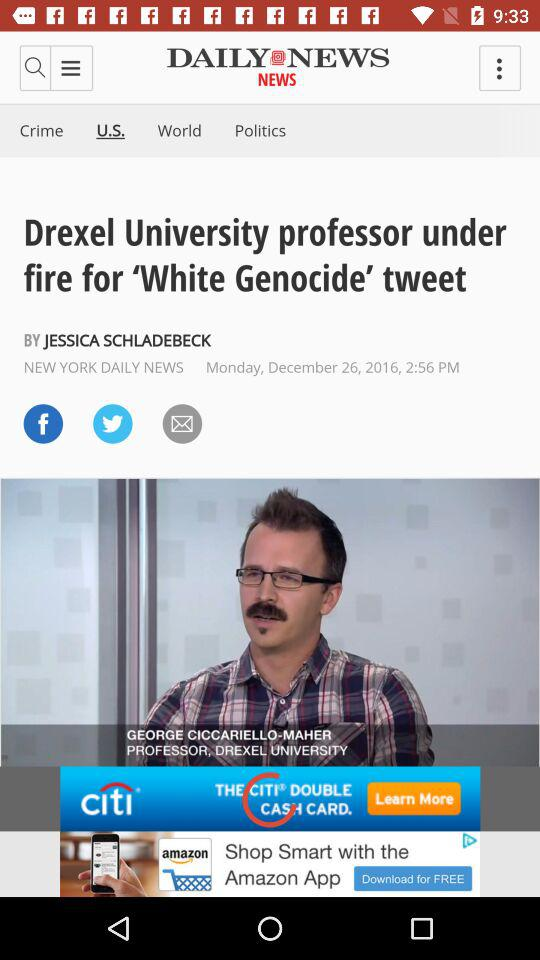When was the news about Drexel University published? The news about Drexel University was published on Monday, December 26, 2016 at 2:56 PM. 